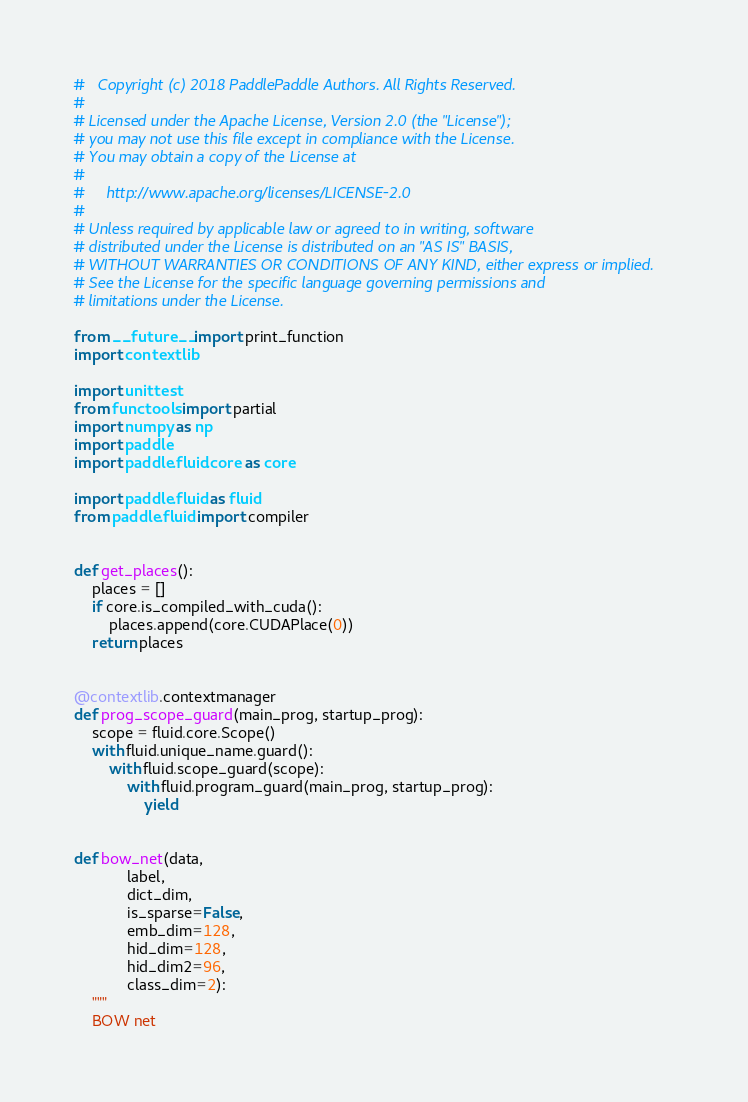Convert code to text. <code><loc_0><loc_0><loc_500><loc_500><_Python_>#   Copyright (c) 2018 PaddlePaddle Authors. All Rights Reserved.
#
# Licensed under the Apache License, Version 2.0 (the "License");
# you may not use this file except in compliance with the License.
# You may obtain a copy of the License at
#
#     http://www.apache.org/licenses/LICENSE-2.0
#
# Unless required by applicable law or agreed to in writing, software
# distributed under the License is distributed on an "AS IS" BASIS,
# WITHOUT WARRANTIES OR CONDITIONS OF ANY KIND, either express or implied.
# See the License for the specific language governing permissions and
# limitations under the License.

from __future__ import print_function
import contextlib

import unittest
from functools import partial
import numpy as np
import paddle
import paddle.fluid.core as core

import paddle.fluid as fluid
from paddle.fluid import compiler


def get_places():
    places = []
    if core.is_compiled_with_cuda():
        places.append(core.CUDAPlace(0))
    return places


@contextlib.contextmanager
def prog_scope_guard(main_prog, startup_prog):
    scope = fluid.core.Scope()
    with fluid.unique_name.guard():
        with fluid.scope_guard(scope):
            with fluid.program_guard(main_prog, startup_prog):
                yield


def bow_net(data,
            label,
            dict_dim,
            is_sparse=False,
            emb_dim=128,
            hid_dim=128,
            hid_dim2=96,
            class_dim=2):
    """
    BOW net</code> 